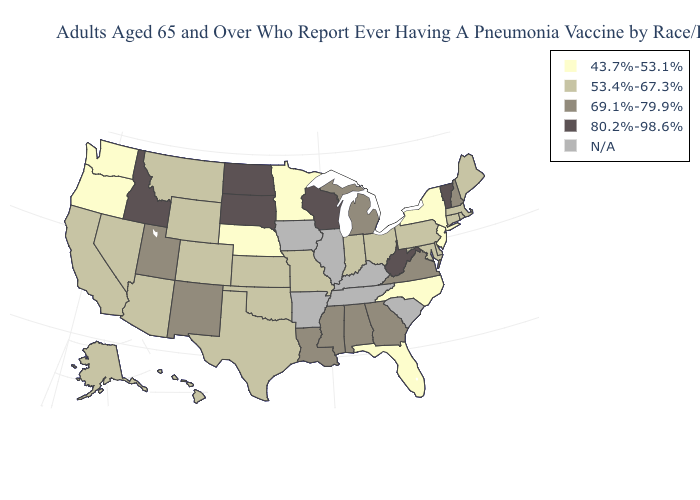Which states have the lowest value in the West?
Keep it brief. Oregon, Washington. Is the legend a continuous bar?
Quick response, please. No. Among the states that border Missouri , which have the lowest value?
Answer briefly. Nebraska. Among the states that border Georgia , does North Carolina have the highest value?
Answer briefly. No. Which states have the highest value in the USA?
Write a very short answer. Idaho, North Dakota, South Dakota, Vermont, West Virginia, Wisconsin. What is the value of Maine?
Concise answer only. 53.4%-67.3%. Name the states that have a value in the range 69.1%-79.9%?
Give a very brief answer. Alabama, Georgia, Louisiana, Michigan, Mississippi, New Hampshire, New Mexico, Utah, Virginia. Does the first symbol in the legend represent the smallest category?
Concise answer only. Yes. What is the value of South Carolina?
Concise answer only. N/A. Name the states that have a value in the range 43.7%-53.1%?
Be succinct. Florida, Minnesota, Nebraska, New Jersey, New York, North Carolina, Oregon, Washington. What is the value of New Mexico?
Give a very brief answer. 69.1%-79.9%. Which states have the highest value in the USA?
Write a very short answer. Idaho, North Dakota, South Dakota, Vermont, West Virginia, Wisconsin. Does Alabama have the lowest value in the South?
Answer briefly. No. What is the lowest value in the MidWest?
Write a very short answer. 43.7%-53.1%. 